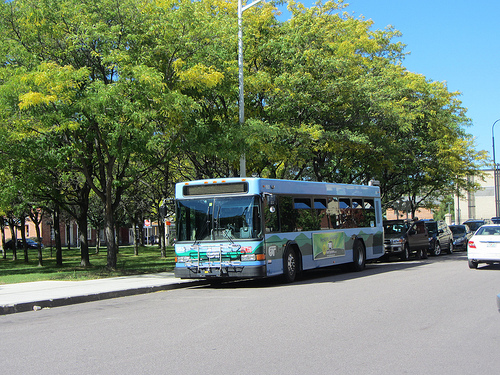What vehicle is the sharegpt4v/same color as the sky? The bus is the sharegpt4v/same blue color as the sky. 